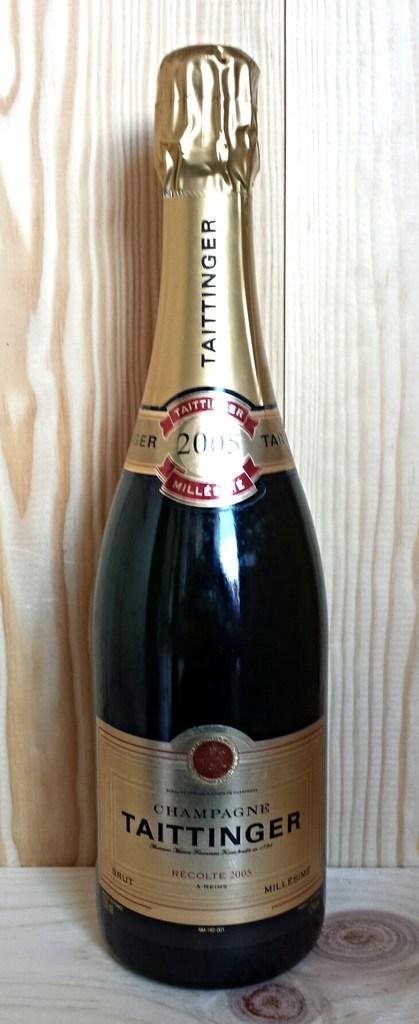What brand is the bottle of wine?
Provide a succinct answer. Taittinger. What year is on this wine bottle?
Ensure brevity in your answer.  2005. 